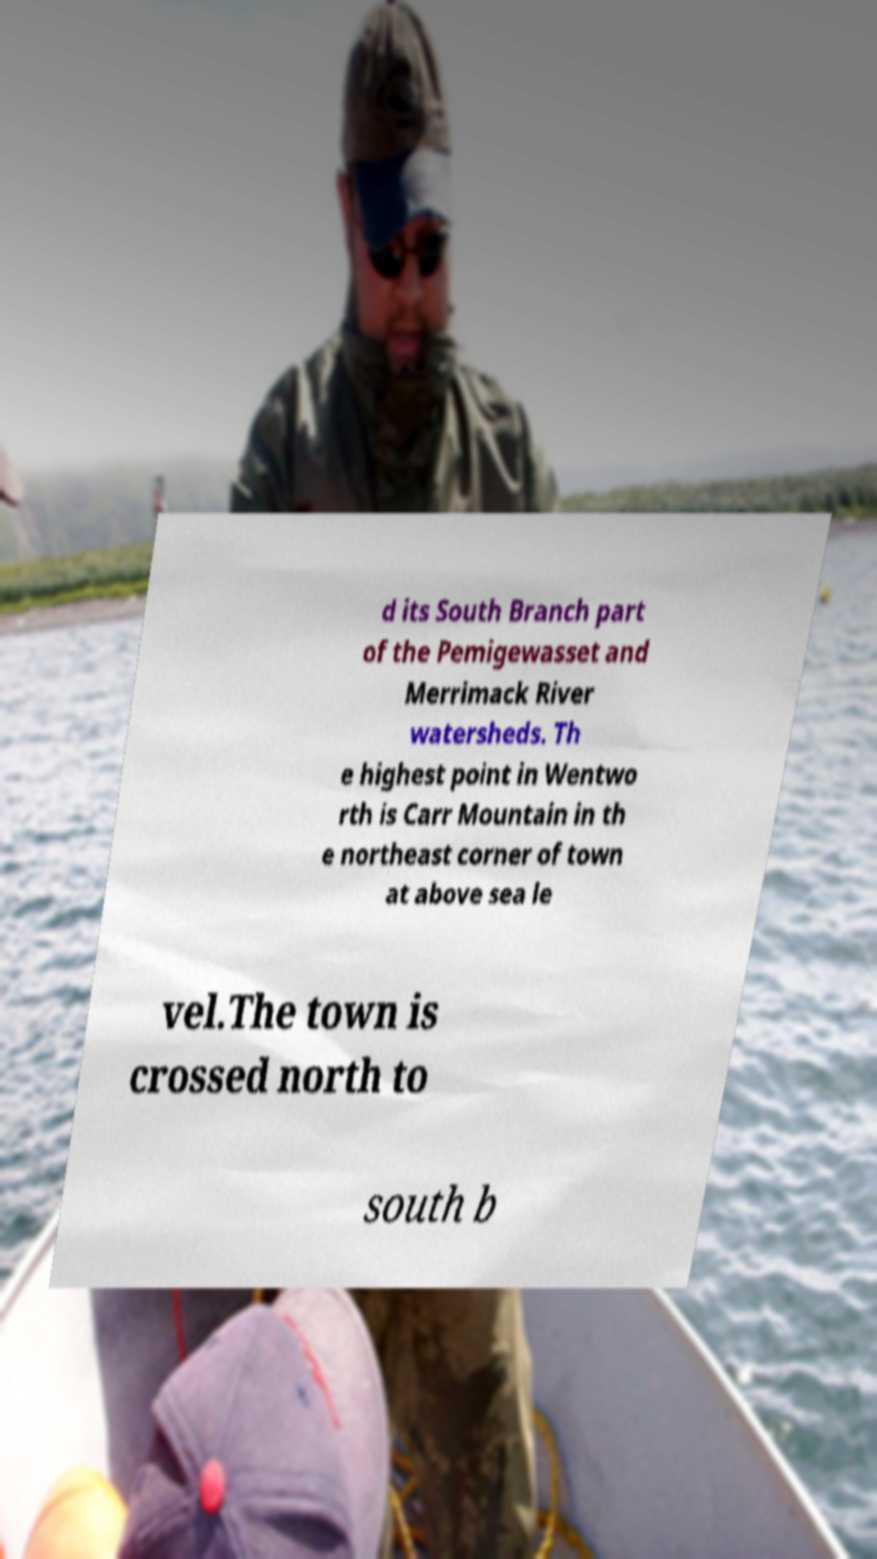Can you read and provide the text displayed in the image?This photo seems to have some interesting text. Can you extract and type it out for me? d its South Branch part of the Pemigewasset and Merrimack River watersheds. Th e highest point in Wentwo rth is Carr Mountain in th e northeast corner of town at above sea le vel.The town is crossed north to south b 